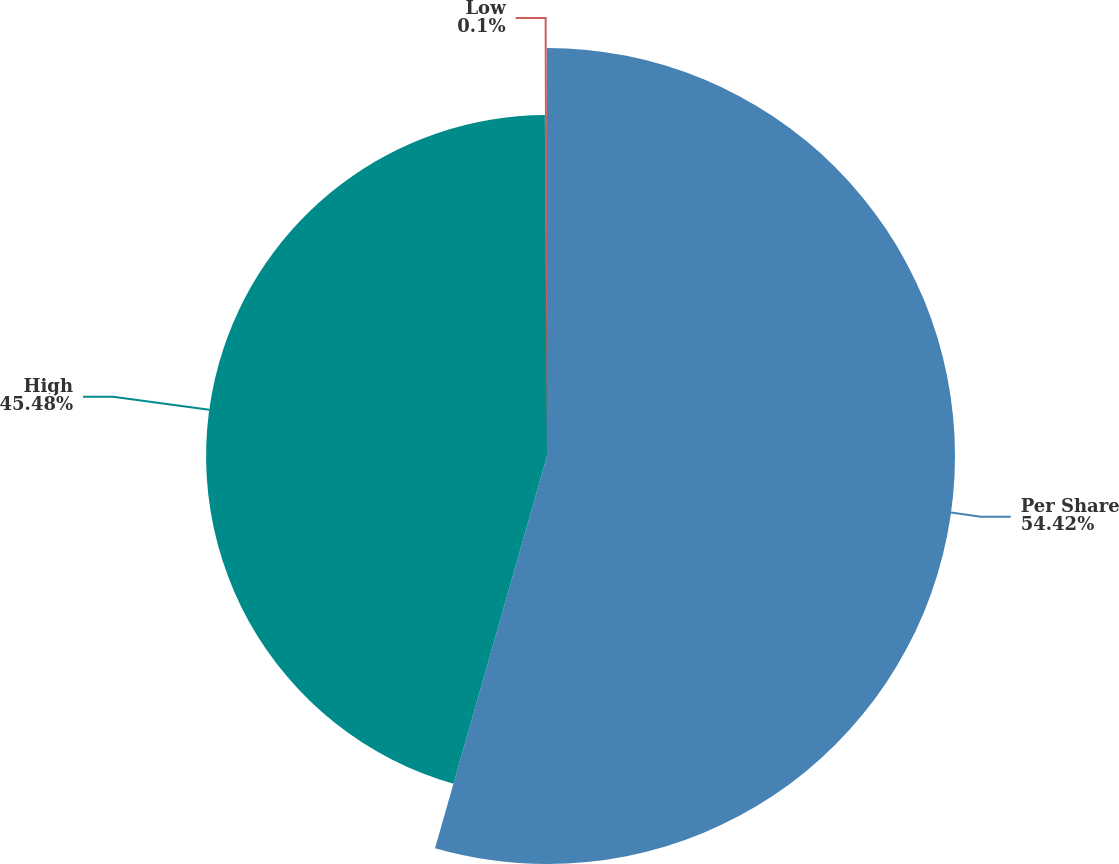Convert chart to OTSL. <chart><loc_0><loc_0><loc_500><loc_500><pie_chart><fcel>Per Share<fcel>High<fcel>Low<nl><fcel>54.43%<fcel>45.48%<fcel>0.1%<nl></chart> 